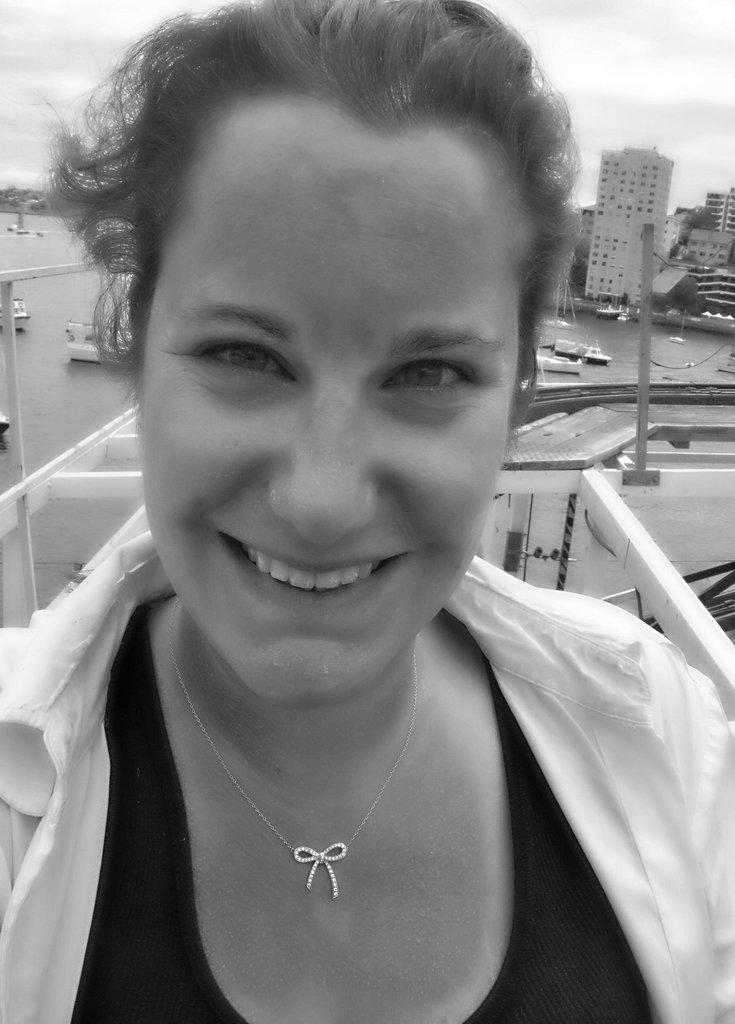In one or two sentences, can you explain what this image depicts? This is a black and white image. In this image we can see a woman. On the backside we can see some buildings, poles, boats in a water body and the sky which looks cloudy. 